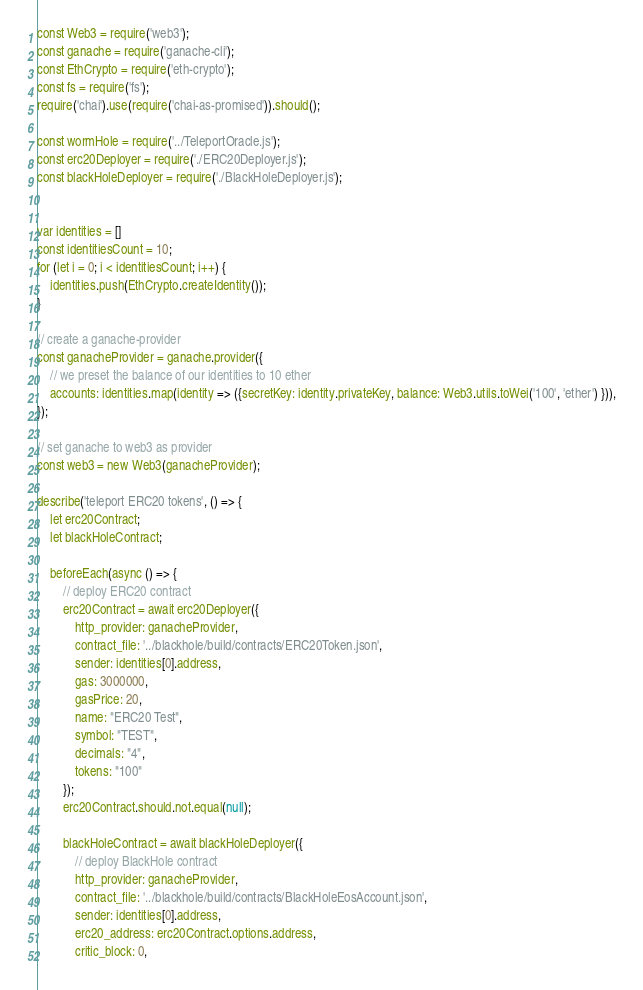Convert code to text. <code><loc_0><loc_0><loc_500><loc_500><_JavaScript_>const Web3 = require('web3');
const ganache = require('ganache-cli');
const EthCrypto = require('eth-crypto');
const fs = require('fs');
require('chai').use(require('chai-as-promised')).should();

const wormHole = require('../TeleportOracle.js');
const erc20Deployer = require('./ERC20Deployer.js');
const blackHoleDeployer = require('./BlackHoleDeployer.js');


var identities = []
const identitiesCount = 10;
for (let i = 0; i < identitiesCount; i++) {
    identities.push(EthCrypto.createIdentity());
}

// create a ganache-provider
const ganacheProvider = ganache.provider({
    // we preset the balance of our identities to 10 ether
    accounts: identities.map(identity => ({secretKey: identity.privateKey, balance: Web3.utils.toWei('100', 'ether') })),
});

// set ganache to web3 as provider
const web3 = new Web3(ganacheProvider);

describe('teleport ERC20 tokens', () => {
    let erc20Contract;
    let blackHoleContract;

    beforeEach(async () => {
        // deploy ERC20 contract
        erc20Contract = await erc20Deployer({
            http_provider: ganacheProvider,
            contract_file: '../blackhole/build/contracts/ERC20Token.json',
            sender: identities[0].address,
            gas: 3000000,
            gasPrice: 20,
            name: "ERC20 Test",
            symbol: "TEST",
            decimals: "4",
            tokens: "100"
        });
        erc20Contract.should.not.equal(null);

        blackHoleContract = await blackHoleDeployer({
            // deploy BlackHole contract
            http_provider: ganacheProvider,
            contract_file: '../blackhole/build/contracts/BlackHoleEosAccount.json',
            sender: identities[0].address,
            erc20_address: erc20Contract.options.address,
            critic_block: 0,</code> 